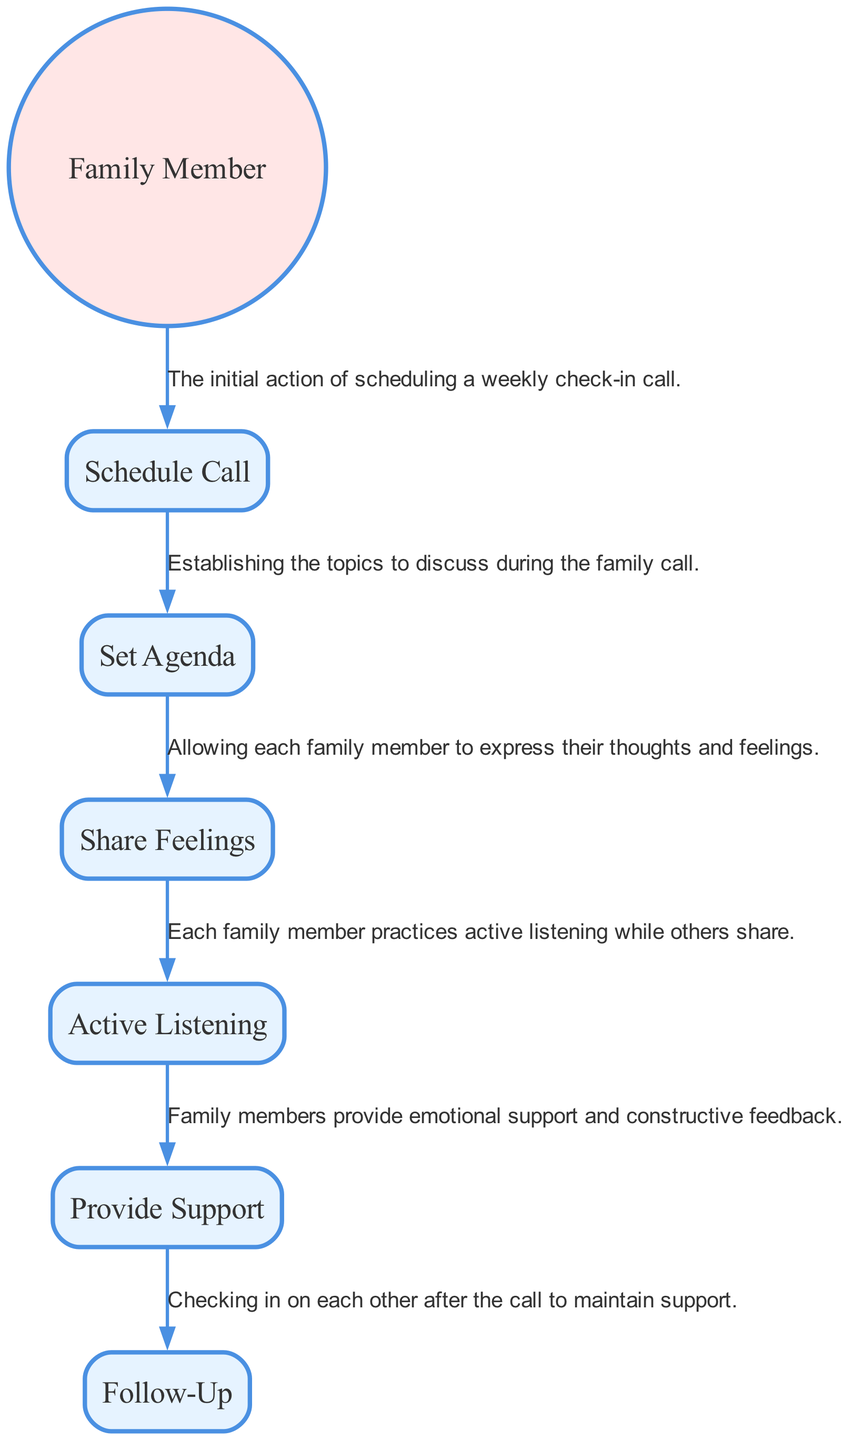What is the first action shown in the diagram? The first action in the sequence is "Schedule Call," which represents the initial step taken by family members to organize a weekly check-in.
Answer: Schedule Call How many actions are depicted in the diagram? There are a total of six actions represented in the diagram, including scheduling the call and various interactive processes.
Answer: 6 Which family member action is connected to providing emotional support? The action "Provide Support" follows after "Share Feelings," indicating the sequence where family members give emotional support.
Answer: Provide Support What action follows after "Set Agenda"? "Share Feelings" is the action that comes immediately after "Set Agenda," showing the flow from establishing topics to sharing thoughts.
Answer: Share Feelings What is the relationship between "Active Listening" and "Share Feelings"? "Active Listening" is conducted while "Share Feelings" occurs, indicating that family members actively listen as each person expresses their feelings.
Answer: Active Listening What is the last action in the diagram? The last action depicted is "Follow-Up," which represents the ongoing check-in process after the family call is completed.
Answer: Follow-Up How many edges connect the actions in the diagram? There are five edges connecting the six actions depicted in the diagram, indicating the flow of activities and interactions.
Answer: 5 Explain the process that involves both "Share Feelings" and "Provide Support". First, family members engage in "Share Feelings," where they express their personal thoughts and emotions. Following this, the action "Provide Support" takes place, where family members respond with encouragement and constructive feedback. This illustrates the interactive nature of the family call.
Answer: Share Feelings, Provide Support 